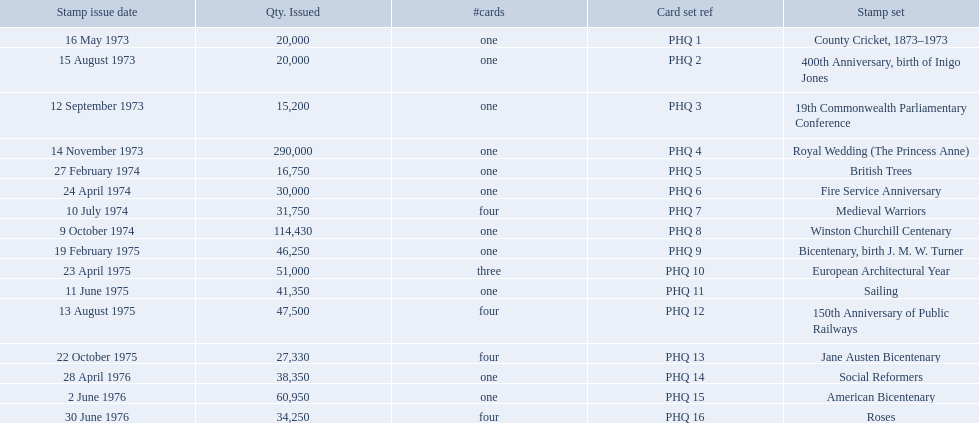What are all the stamp sets? County Cricket, 1873–1973, 400th Anniversary, birth of Inigo Jones, 19th Commonwealth Parliamentary Conference, Royal Wedding (The Princess Anne), British Trees, Fire Service Anniversary, Medieval Warriors, Winston Churchill Centenary, Bicentenary, birth J. M. W. Turner, European Architectural Year, Sailing, 150th Anniversary of Public Railways, Jane Austen Bicentenary, Social Reformers, American Bicentenary, Roses. For these sets, what were the quantities issued? 20,000, 20,000, 15,200, 290,000, 16,750, 30,000, 31,750, 114,430, 46,250, 51,000, 41,350, 47,500, 27,330, 38,350, 60,950, 34,250. Of these, which quantity is above 200,000? 290,000. What is the stamp set corresponding to this quantity? Royal Wedding (The Princess Anne). 